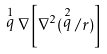<formula> <loc_0><loc_0><loc_500><loc_500>\stackrel { 1 } { q } \nabla \left [ \nabla ^ { 2 } ( \stackrel { 2 } { q } / r ) \right ]</formula> 